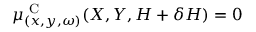<formula> <loc_0><loc_0><loc_500><loc_500>\mu _ { ( x , y , \omega ) } ^ { C } ( X , Y , H + \delta H ) = 0</formula> 